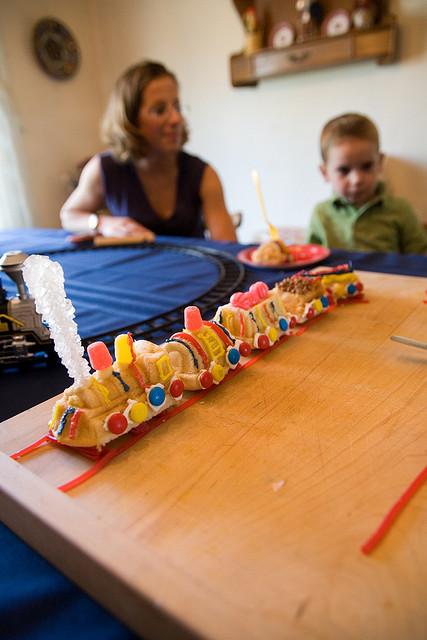Is the train edible?
Give a very brief answer. Yes. What color is the track on the wood table?
Concise answer only. Red. Is the child touching the train?
Concise answer only. No. Is the baby happy?
Write a very short answer. No. 